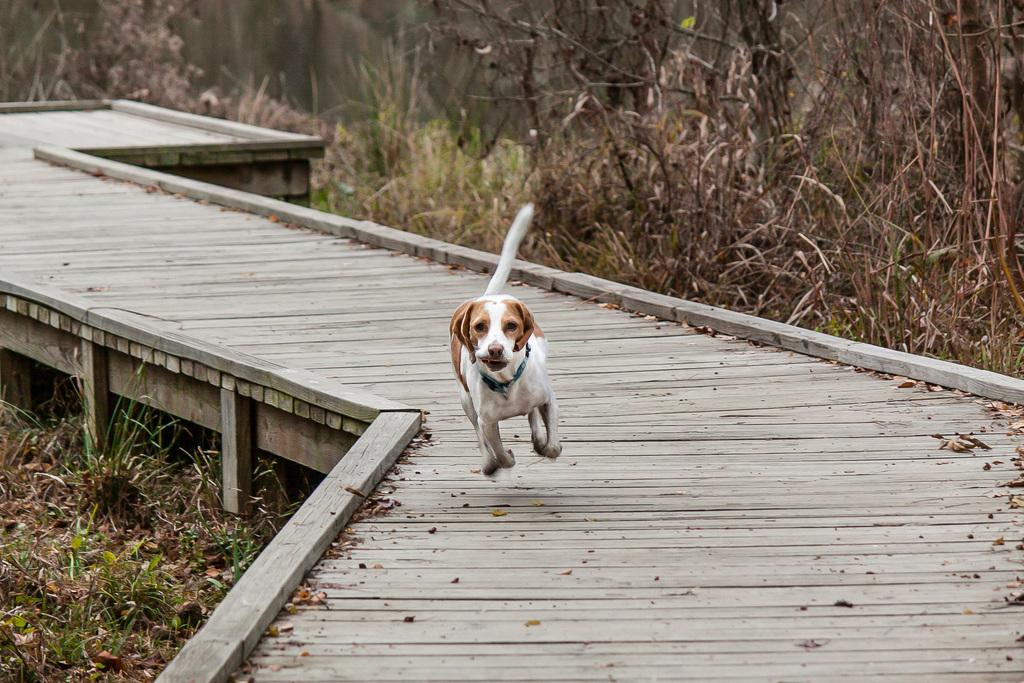What animal can be seen in the image? There is a dog in the image. What is the dog doing in the image? The dog is running on a wooden bridge. What type of vegetation is visible in the background of the image? There are plants and grass in the background of the image. What type of ray is swimming under the wooden bridge in the image? There is no ray present in the image; it features a dog running on a wooden bridge. What kind of experience does the dog have while running on the wooden bridge in the image? The image does not provide information about the dog's experience while running on the wooden bridge. 